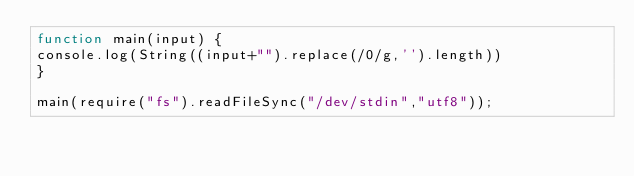<code> <loc_0><loc_0><loc_500><loc_500><_JavaScript_>function main(input) {
console.log(String((input+"").replace(/0/g,'').length))
}
 
main(require("fs").readFileSync("/dev/stdin","utf8"));</code> 